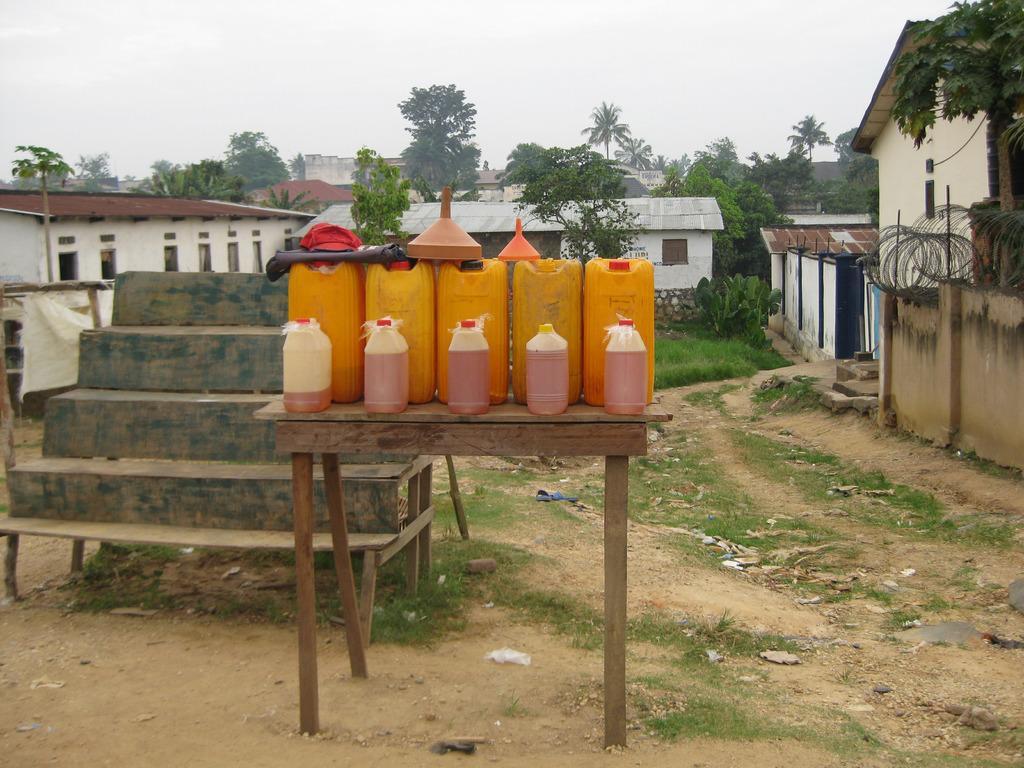How would you summarize this image in a sentence or two? In the center of the image there is a table. On top of it there are cans and a few other objects. On the left side of the image there are wooden stairs. In the background of the image there is grass on the surface. There are buildings, trees and sky. 